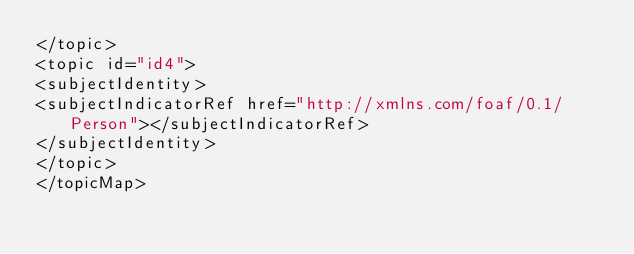<code> <loc_0><loc_0><loc_500><loc_500><_XML_></topic>
<topic id="id4">
<subjectIdentity>
<subjectIndicatorRef href="http://xmlns.com/foaf/0.1/Person"></subjectIndicatorRef>
</subjectIdentity>
</topic>
</topicMap>
</code> 